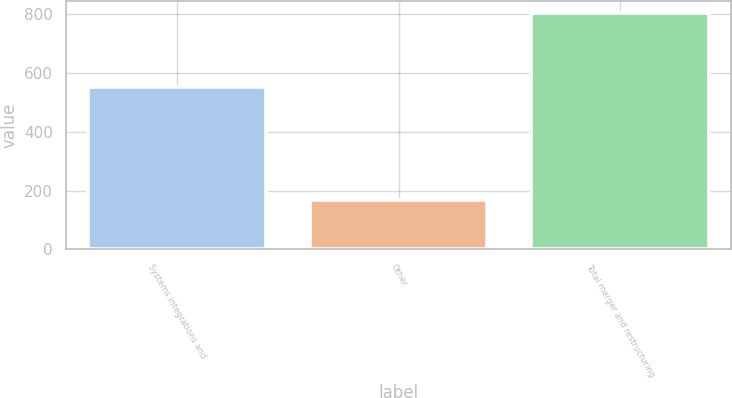Convert chart. <chart><loc_0><loc_0><loc_500><loc_500><bar_chart><fcel>Systems integrations and<fcel>Other<fcel>Total merger and restructuring<nl><fcel>552<fcel>168<fcel>805<nl></chart> 